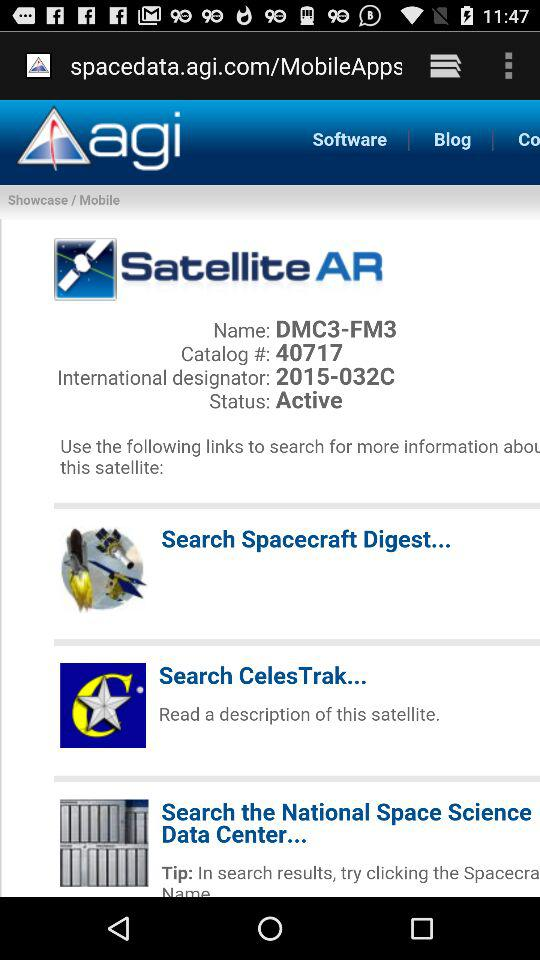What international designator is used for the satellite? The international designator used for the satellite is 2015-032C. 